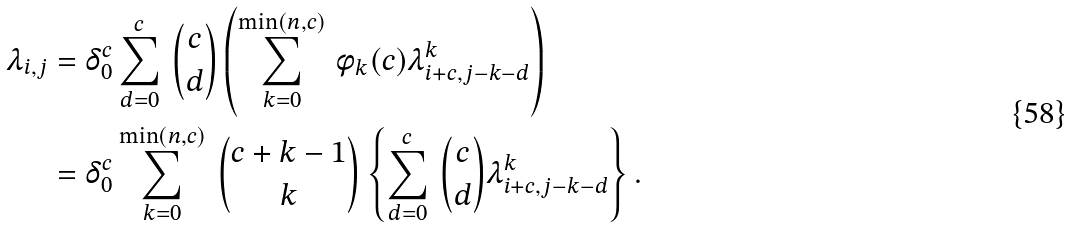<formula> <loc_0><loc_0><loc_500><loc_500>\lambda _ { i , j } & = \delta _ { 0 } ^ { c } \sum _ { d = 0 } ^ { c } \, { c \choose d } \left ( \sum _ { k = 0 } ^ { \min ( n , c ) } \, \phi _ { k } ( c ) \lambda _ { i + c , j - k - d } ^ { k } \right ) \\ & = \delta _ { 0 } ^ { c } \sum _ { k = 0 } ^ { \min ( n , c ) } \, { c + k - 1 \choose k } \left \{ \sum _ { d = 0 } ^ { c } \, { c \choose d } \lambda _ { i + c , j - k - d } ^ { k } \right \} .</formula> 